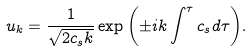<formula> <loc_0><loc_0><loc_500><loc_500>u _ { k } = \frac { 1 } { \sqrt { 2 c _ { s } k } } \exp { \left ( \pm i k \int ^ { \tau } c _ { s } d \tau \right ) } .</formula> 